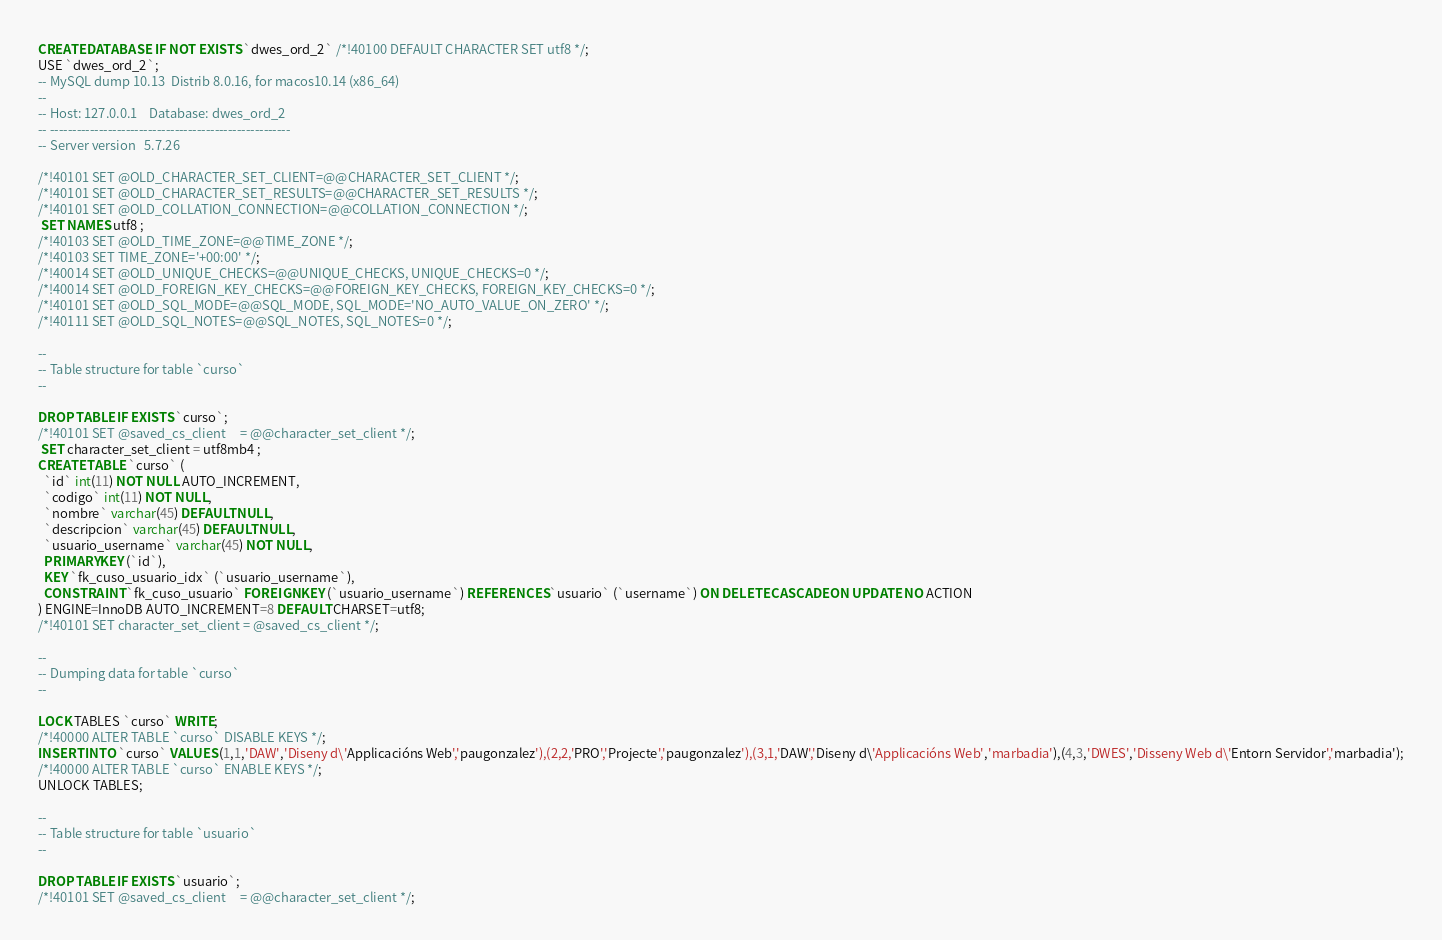<code> <loc_0><loc_0><loc_500><loc_500><_SQL_>CREATE DATABASE  IF NOT EXISTS `dwes_ord_2` /*!40100 DEFAULT CHARACTER SET utf8 */;
USE `dwes_ord_2`;
-- MySQL dump 10.13  Distrib 8.0.16, for macos10.14 (x86_64)
--
-- Host: 127.0.0.1    Database: dwes_ord_2
-- ------------------------------------------------------
-- Server version	5.7.26

/*!40101 SET @OLD_CHARACTER_SET_CLIENT=@@CHARACTER_SET_CLIENT */;
/*!40101 SET @OLD_CHARACTER_SET_RESULTS=@@CHARACTER_SET_RESULTS */;
/*!40101 SET @OLD_COLLATION_CONNECTION=@@COLLATION_CONNECTION */;
 SET NAMES utf8 ;
/*!40103 SET @OLD_TIME_ZONE=@@TIME_ZONE */;
/*!40103 SET TIME_ZONE='+00:00' */;
/*!40014 SET @OLD_UNIQUE_CHECKS=@@UNIQUE_CHECKS, UNIQUE_CHECKS=0 */;
/*!40014 SET @OLD_FOREIGN_KEY_CHECKS=@@FOREIGN_KEY_CHECKS, FOREIGN_KEY_CHECKS=0 */;
/*!40101 SET @OLD_SQL_MODE=@@SQL_MODE, SQL_MODE='NO_AUTO_VALUE_ON_ZERO' */;
/*!40111 SET @OLD_SQL_NOTES=@@SQL_NOTES, SQL_NOTES=0 */;

--
-- Table structure for table `curso`
--

DROP TABLE IF EXISTS `curso`;
/*!40101 SET @saved_cs_client     = @@character_set_client */;
 SET character_set_client = utf8mb4 ;
CREATE TABLE `curso` (
  `id` int(11) NOT NULL AUTO_INCREMENT,
  `codigo` int(11) NOT NULL,
  `nombre` varchar(45) DEFAULT NULL,
  `descripcion` varchar(45) DEFAULT NULL,
  `usuario_username` varchar(45) NOT NULL,
  PRIMARY KEY (`id`),
  KEY `fk_cuso_usuario_idx` (`usuario_username`),
  CONSTRAINT `fk_cuso_usuario` FOREIGN KEY (`usuario_username`) REFERENCES `usuario` (`username`) ON DELETE CASCADE ON UPDATE NO ACTION
) ENGINE=InnoDB AUTO_INCREMENT=8 DEFAULT CHARSET=utf8;
/*!40101 SET character_set_client = @saved_cs_client */;

--
-- Dumping data for table `curso`
--

LOCK TABLES `curso` WRITE;
/*!40000 ALTER TABLE `curso` DISABLE KEYS */;
INSERT INTO `curso` VALUES (1,1,'DAW','Diseny d\'Applicacións Web','paugonzalez'),(2,2,'PRO','Projecte','paugonzalez'),(3,1,'DAW','Diseny d\'Applicacións Web','marbadia'),(4,3,'DWES','Disseny Web d\'Entorn Servidor','marbadia');
/*!40000 ALTER TABLE `curso` ENABLE KEYS */;
UNLOCK TABLES;

--
-- Table structure for table `usuario`
--

DROP TABLE IF EXISTS `usuario`;
/*!40101 SET @saved_cs_client     = @@character_set_client */;</code> 